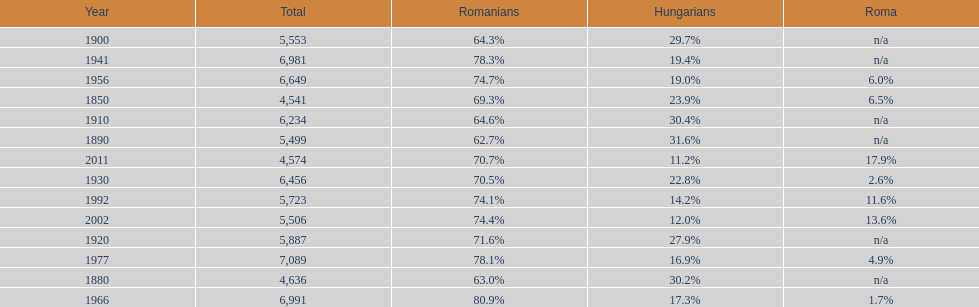What year had the next highest percentage for roma after 2011? 2002. 